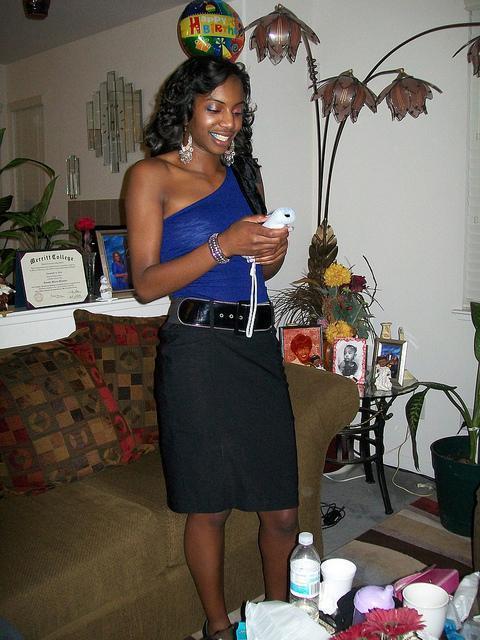How many couches can be seen?
Give a very brief answer. 2. How many potted plants can be seen?
Give a very brief answer. 3. 